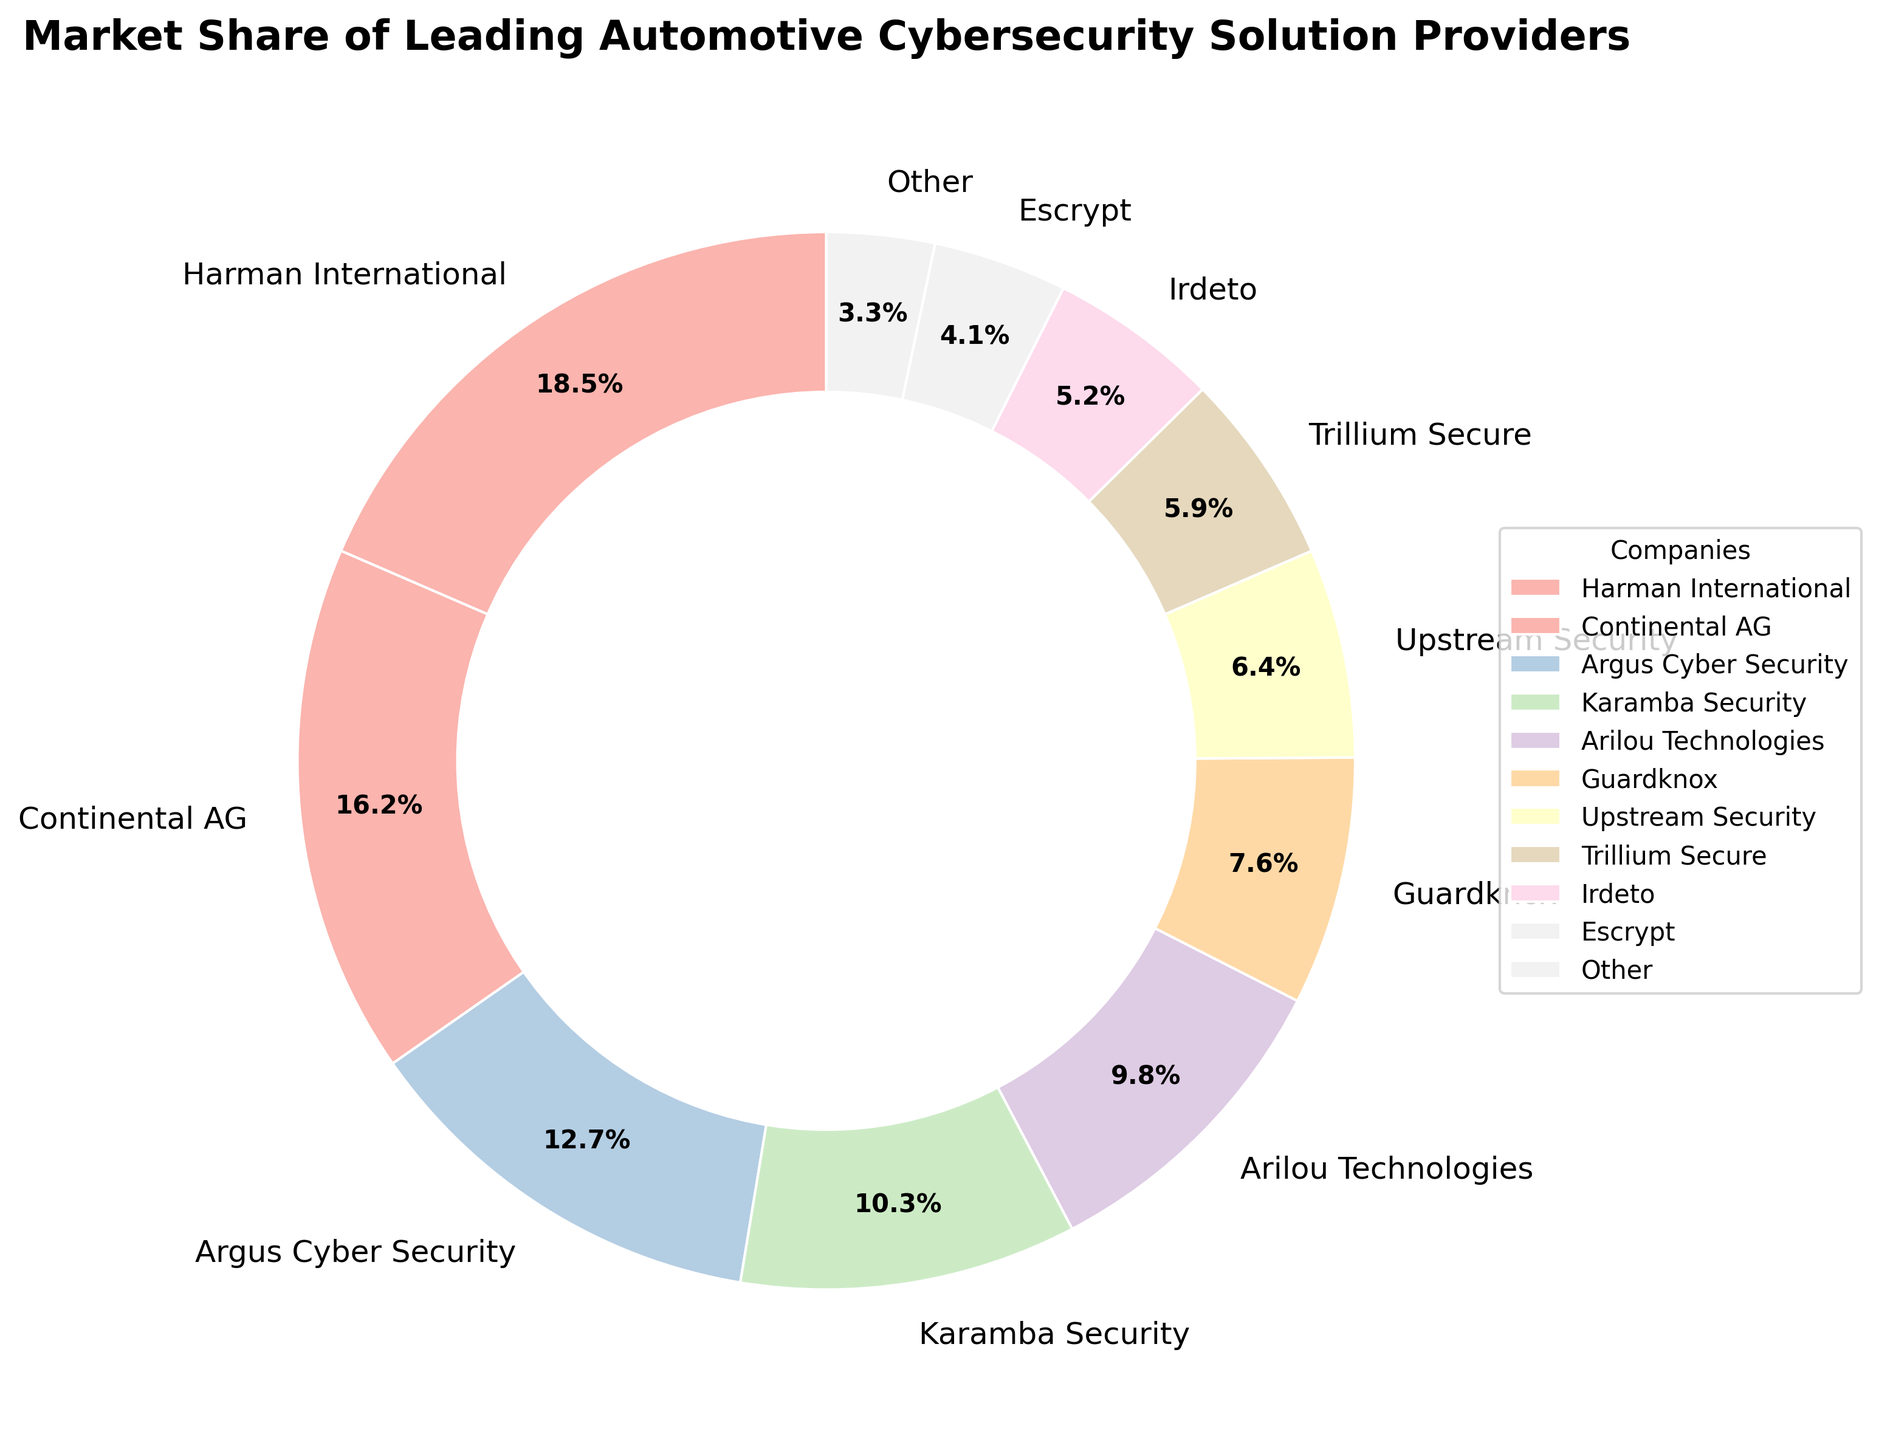Which company has the largest market share in automotive cybersecurity solutions? The company with the largest market share is identified by the biggest wedge in the pie chart, which is labeled as Harman International.
Answer: Harman International What is the combined market share of Guardknox and Upstream Security? To find the combined market share, add the individual market shares of Guardknox (7.6%) and Upstream Security (6.4%). The calculation is 7.6 + 6.4 = 14.0%.
Answer: 14.0% How does the market share of Argus Cyber Security compare to Arilou Technologies? Argus Cyber Security holds 12.7% of the market share while Arilou Technologies holds 9.8%, meaning Argus Cyber Security has a larger market share.
Answer: Argus Cyber Security has a larger market share Which company holds the smallest market share among the listed companies? The company with the smallest wedge in the pie chart, indicating the smallest market share, is Escrypt with 4.1%.
Answer: Escrypt How much greater is the market share of Harman International compared to Irdeto? Subtract the market share of Irdeto (5.2%) from Harman International (18.5%) to find the difference: 18.5 - 5.2 = 13.3%.
Answer: 13.3% What’s the total market share of the top three companies? Sum the market shares of the top three companies: Harman International (18.5%), Continental AG (16.2%), and Argus Cyber Security (12.7%). The calculation is 18.5 + 16.2 + 12.7 = 47.4%.
Answer: 47.4% Which three companies have the closest market shares to each other and what are their combined market shares? The three companies with the closest market shares are Karamba Security (10.3%), Arilou Technologies (9.8%), and Guardknox (7.6%). Their combined market share is 10.3 + 9.8 + 7.6 = 27.7%.
Answer: Karamba Security, Arilou Technologies, and Guardknox have a combined market share of 27.7% In terms of market share, how do Karamba Security and Trillium Secure compare to the combined market share of "Other"? The combined market share of Karamba Security (10.3%) and Trillium Secure (5.9%) is 10.3 + 5.9 = 16.2%, which is significantly higher than the market share labeled as "Other" (3.3%).
Answer: Karamba Security and Trillium Secure have a higher combined market share Which company has a market share close to 10%? The company with a market share close to 10% is Karamba Security with 10.3%.
Answer: Karamba Security How many companies have a market share greater than 10% and which are they? Count and list the companies with market shares greater than 10%: Harman International (18.5%), Continental AG (16.2%), Argus Cyber Security (12.7%), and Karamba Security (10.3%), resulting in four companies.
Answer: Four companies: Harman International, Continental AG, Argus Cyber Security, Karamba Security 